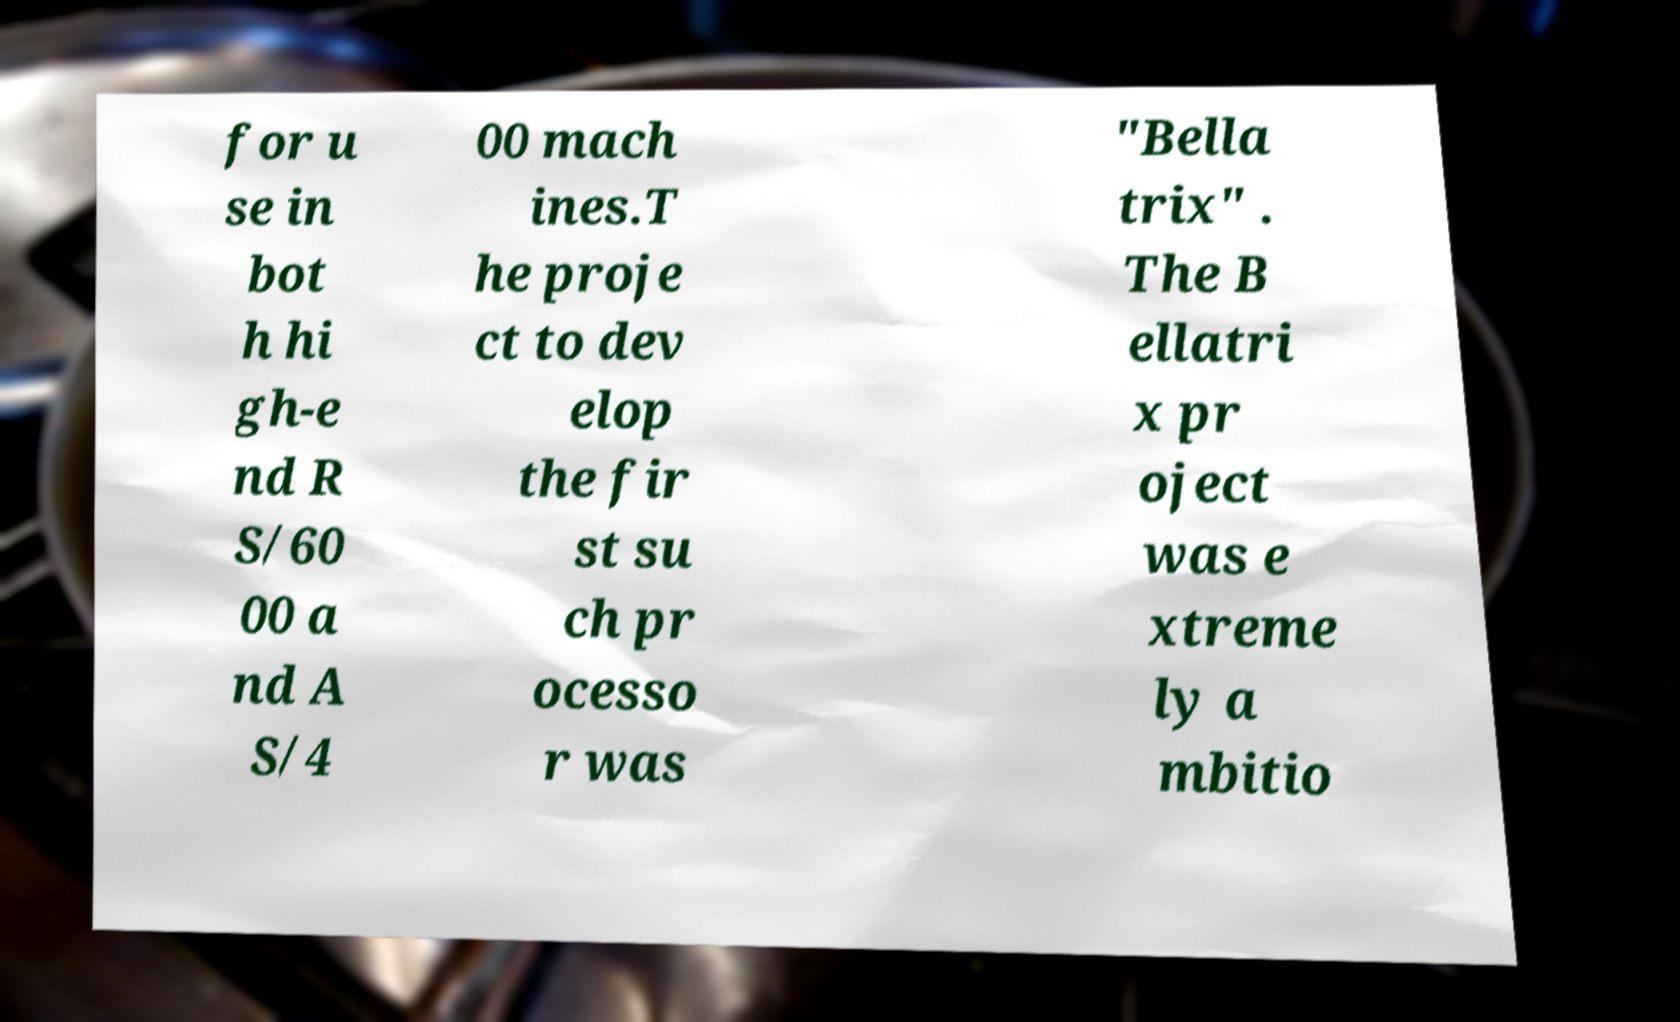What messages or text are displayed in this image? I need them in a readable, typed format. for u se in bot h hi gh-e nd R S/60 00 a nd A S/4 00 mach ines.T he proje ct to dev elop the fir st su ch pr ocesso r was "Bella trix" . The B ellatri x pr oject was e xtreme ly a mbitio 